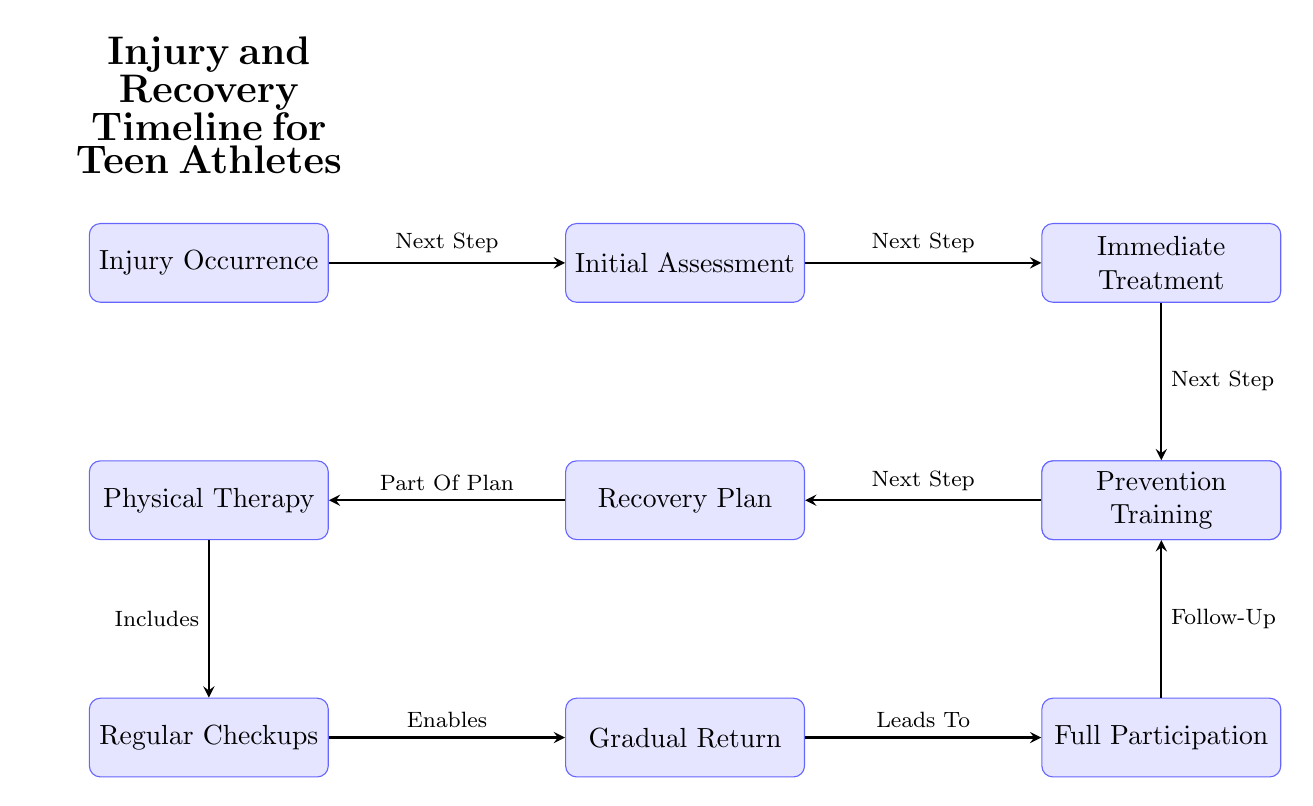What is the first step in the recovery timeline? The first step indicated in the diagram is the "Injury Occurrence," as it is the starting point of the timeline.
Answer: Injury Occurrence How many main steps are shown in the diagram? Counting the nodes visually, there are a total of 9 main steps in the recovery timeline presented in the diagram.
Answer: 9 What step follows the "Initial Assessment"? The diagram shows that the "Immediate Treatment" is the step that follows the "Initial Assessment."
Answer: Immediate Treatment Which step leads to "Full Participation"? According to the flow in the diagram, the "Gradual Return" step leads to "Full Participation."
Answer: Gradual Return How is the "Recovery Plan" related to "Physical Therapy"? The diagram indicates that "Physical Therapy" is part of the "Recovery Plan," which connects the two processes directly.
Answer: Part Of Plan What step does "Regular Checkups" enable? The diagram clearly states that "Regular Checkups" enables the "Gradual Return" step, showing the progression from one to the other.
Answer: Gradual Return What is the final step in the recovery timeline? The last step depicted in the diagram is "Prevention Training," which comes after "Full Participation."
Answer: Prevention Training How does "Immediate Treatment" connect to "Medical Diagnosis"? The arrow between "Immediate Treatment" and "Medical Diagnosis" shows that "Immediate Treatment" directly leads to the "Medical Diagnosis" step in the timeline.
Answer: Next Step What step comes after the "Medical Diagnosis"? Following the "Medical Diagnosis," the next step, according to the diagram, is the "Recovery Plan."
Answer: Recovery Plan 